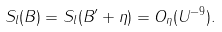<formula> <loc_0><loc_0><loc_500><loc_500>S _ { l } ( B ) = S _ { l } ( B ^ { \prime } + \eta ) = O _ { \eta } ( U ^ { - 9 } ) .</formula> 